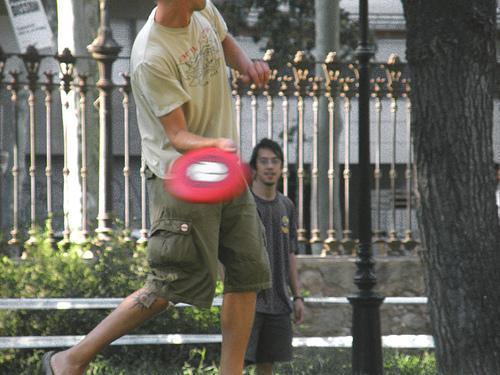What is tattooed on his right leg?
Pick the right solution, then justify: 'Answer: answer
Rationale: rationale.'
Options: Gun, brain, heart, flag. Answer: heart.
Rationale: A heart is on his leg. 